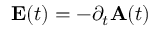Convert formula to latex. <formula><loc_0><loc_0><loc_500><loc_500>E ( t ) = - \partial _ { t } A ( t )</formula> 